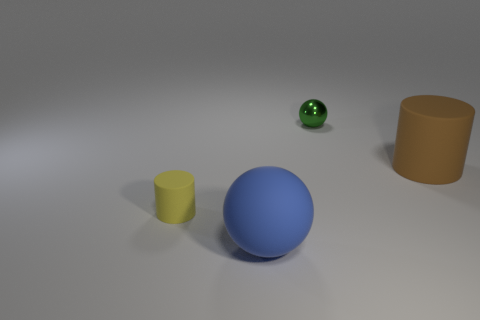How many other things are the same size as the brown cylinder? Upon observing the image, there is one yellow cylinder that appears to be the same size as the brown cylinder. Determining the exact size merely by visual inspection can be challenging. However, based on their similar shapes and proportions, we can infer that there is one object, the yellow cylinder, matching the size of the brown cylinder. 